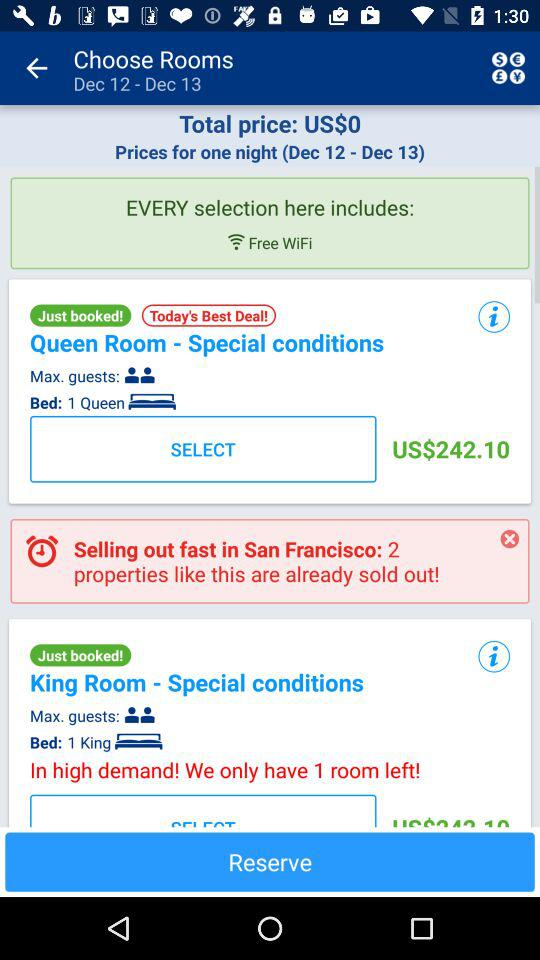What service is free in "Every selection here includes:"? The service is free WiFi. 